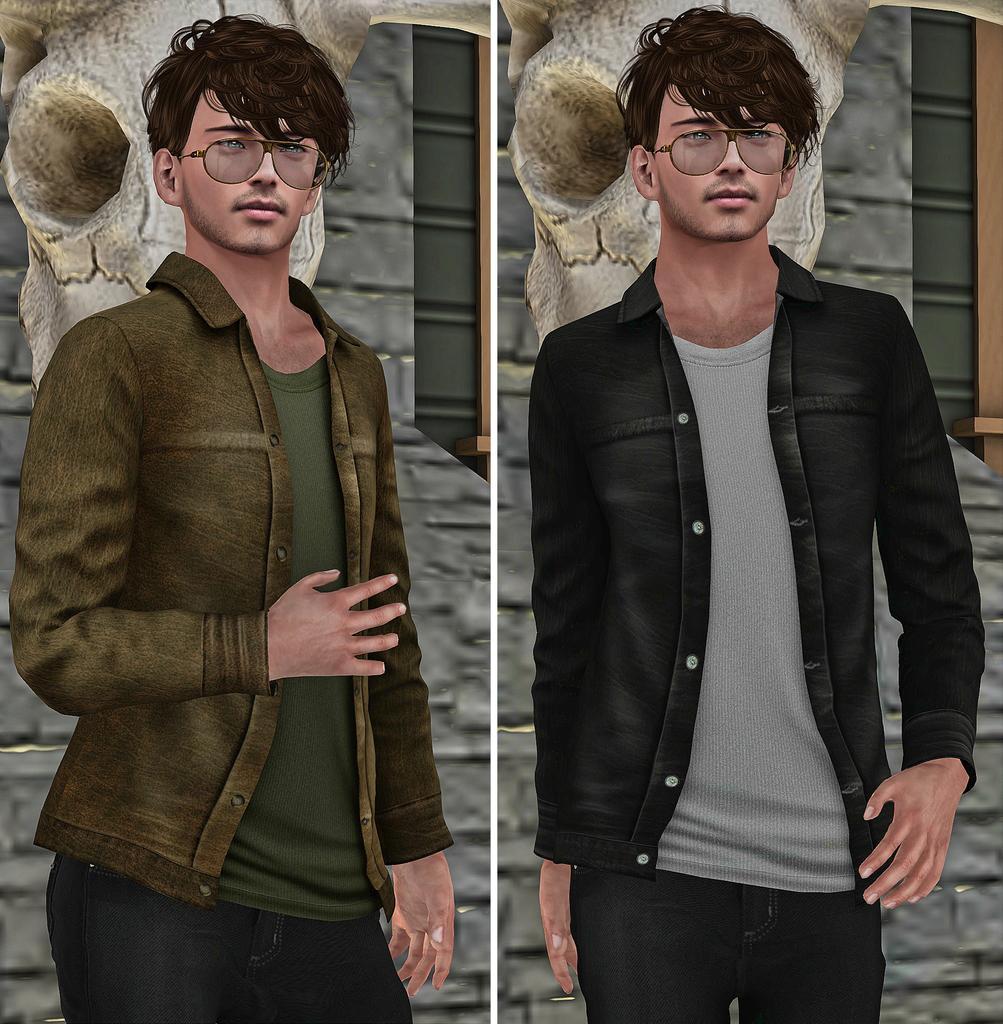In one or two sentences, can you explain what this image depicts? This image is an animated image. This image is a collage of two images. Both are same images. In the background there is a wall. In the middle of the image a man is standing. 